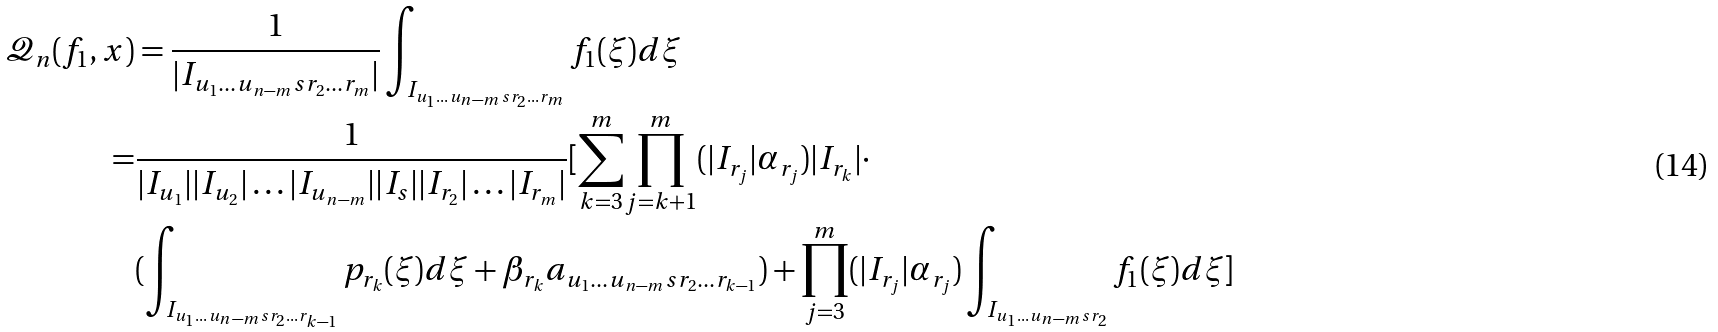<formula> <loc_0><loc_0><loc_500><loc_500>\mathcal { Q } _ { n } ( f _ { 1 } , x ) & = \frac { 1 } { | I _ { { u _ { 1 } } \dots { u _ { n - m } } s { r _ { 2 } } \dots { r _ { m } } } | } \int _ { I _ { { u _ { 1 } } \dots { u _ { n - m } } s { r _ { 2 } } \dots { r _ { m } } } } f _ { 1 } ( \xi ) d \xi \\ = & \frac { 1 } { { | I _ { u _ { 1 } } | | I _ { u _ { 2 } } | \dots | I _ { u _ { n - m } } | | I _ { s } | | I _ { r _ { 2 } } | \dots | I _ { r _ { m } } | } } [ \underset { k = 3 } { \overset { m } \sum } \underset { j = k + 1 } { \overset { m } \prod } ( | I _ { r _ { j } } | \alpha _ { r _ { j } } ) | I _ { r _ { k } } | \cdot \\ & ( \int _ { I _ { { u _ { 1 } } \dots { u _ { n - m } } s { r _ { 2 } } \dots { r _ { k - 1 } } } } p _ { r _ { k } } ( \xi ) d \xi + \beta _ { r _ { k } } a _ { { u _ { 1 } } \dots { u _ { n - m } } s { r _ { 2 } } \dots { r _ { k - 1 } } } ) + \underset { j = 3 } { \overset { m } \prod } ( | I _ { r _ { j } } | \alpha _ { r _ { j } } ) \int _ { I _ { { u _ { 1 } } \dots { u _ { n - m } } s { r _ { 2 } } } } f _ { 1 } ( \xi ) d \xi ]</formula> 